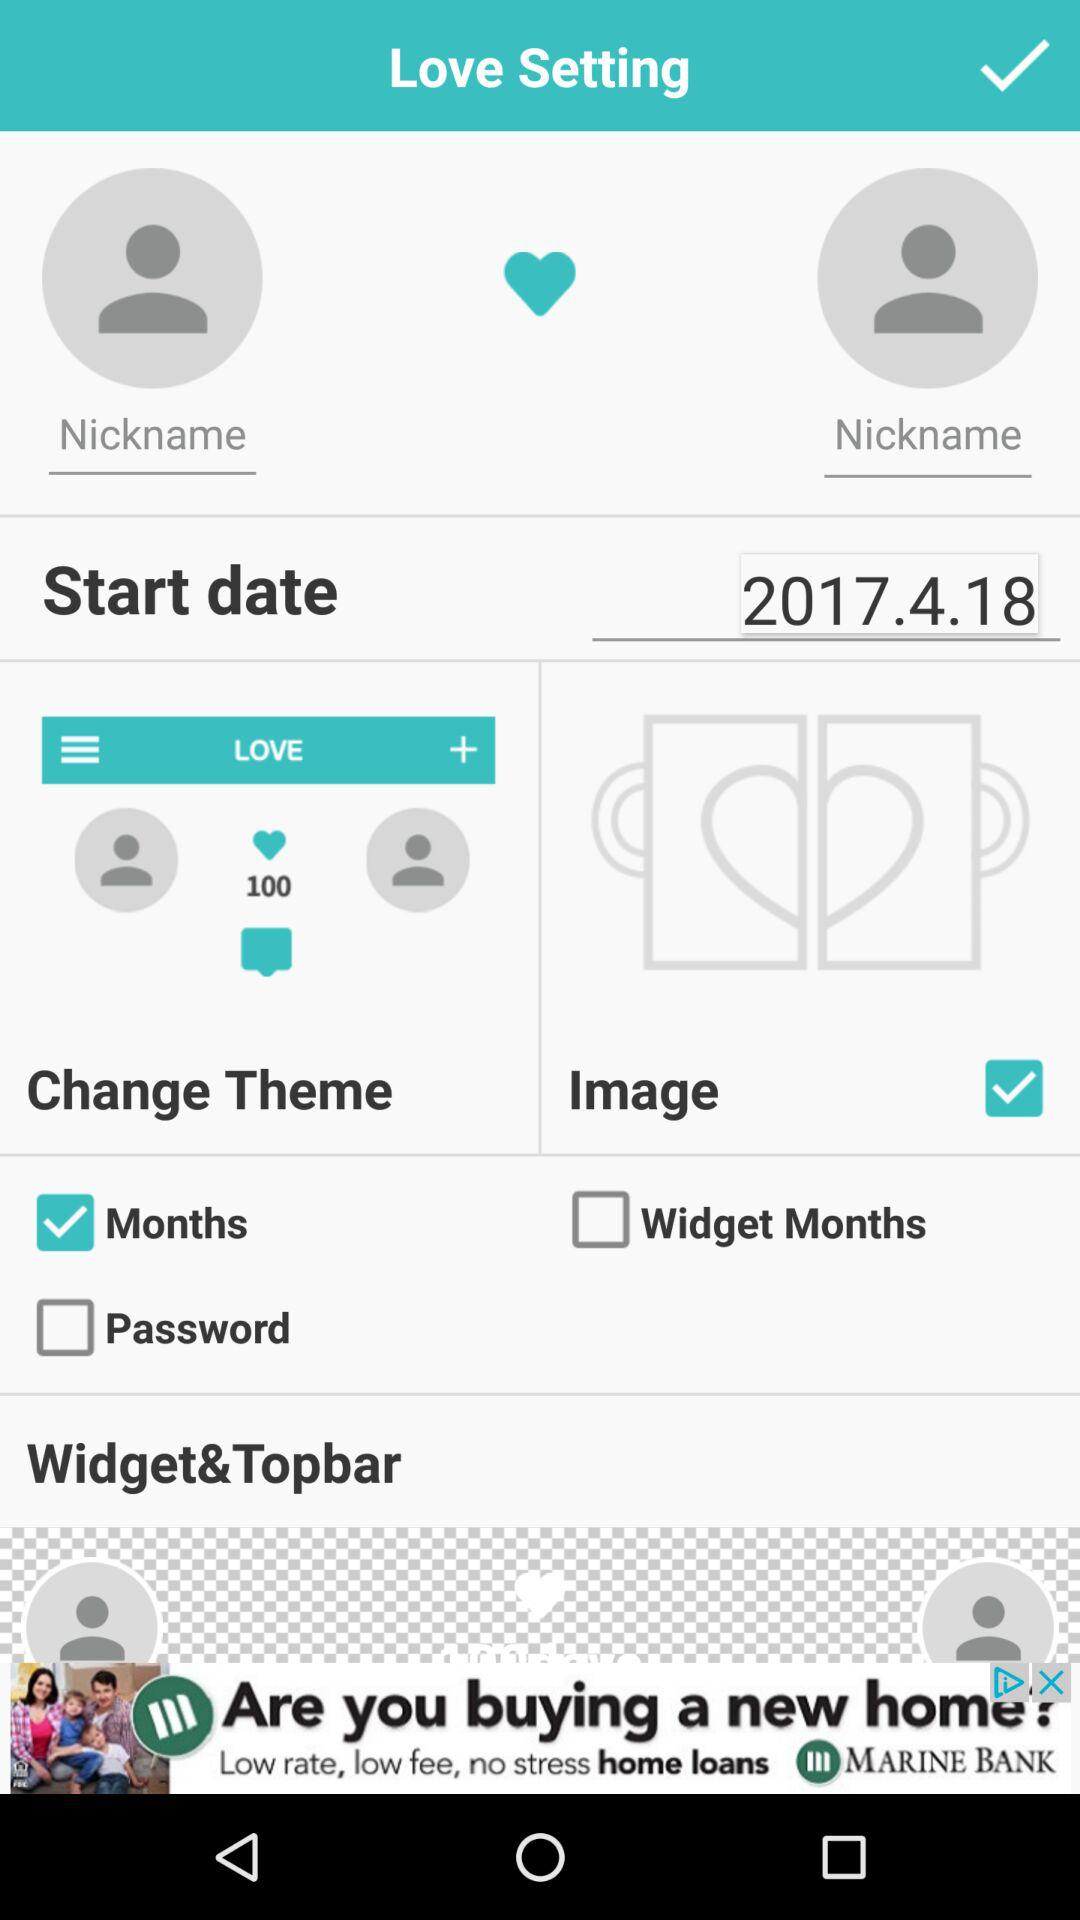What is the start date in "Love Setting"? The start date is April 18, 2017. 